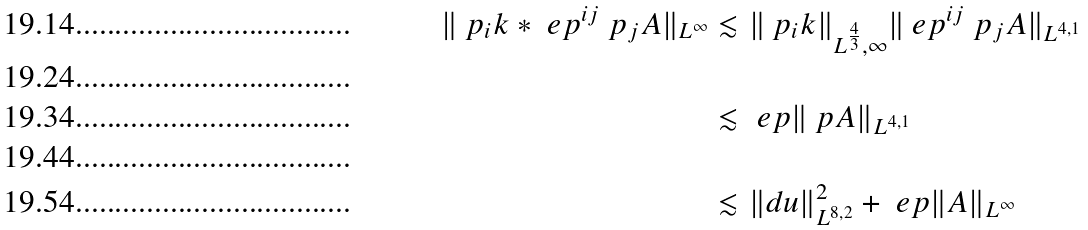Convert formula to latex. <formula><loc_0><loc_0><loc_500><loc_500>\| \ p _ { i } k \ast \ e p ^ { i j } \ p _ { j } A \| _ { L ^ { \infty } } & \lesssim \| \ p _ { i } k \| _ { L ^ { \frac { 4 } { 3 } } , \infty } \| \ e p ^ { i j } \ p _ { j } A \| _ { L ^ { 4 , 1 } } \\ \\ & \lesssim \ e p \| \ p A \| _ { L ^ { 4 , 1 } } \\ \\ & \lesssim \| d u \| _ { L ^ { 8 , 2 } } ^ { 2 } + \ e p \| A \| _ { L ^ { \infty } }</formula> 